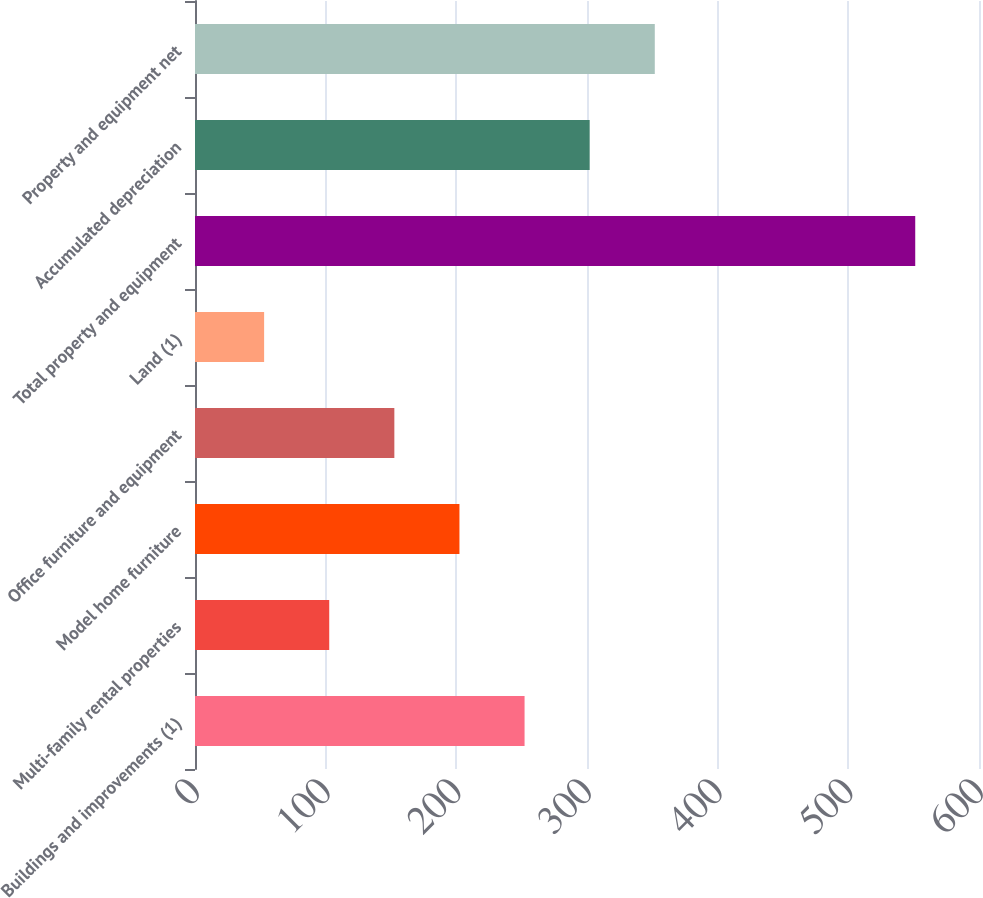Convert chart to OTSL. <chart><loc_0><loc_0><loc_500><loc_500><bar_chart><fcel>Buildings and improvements (1)<fcel>Multi-family rental properties<fcel>Model home furniture<fcel>Office furniture and equipment<fcel>Land (1)<fcel>Total property and equipment<fcel>Accumulated depreciation<fcel>Property and equipment net<nl><fcel>252.22<fcel>102.73<fcel>202.39<fcel>152.56<fcel>52.9<fcel>551.2<fcel>302.05<fcel>351.88<nl></chart> 